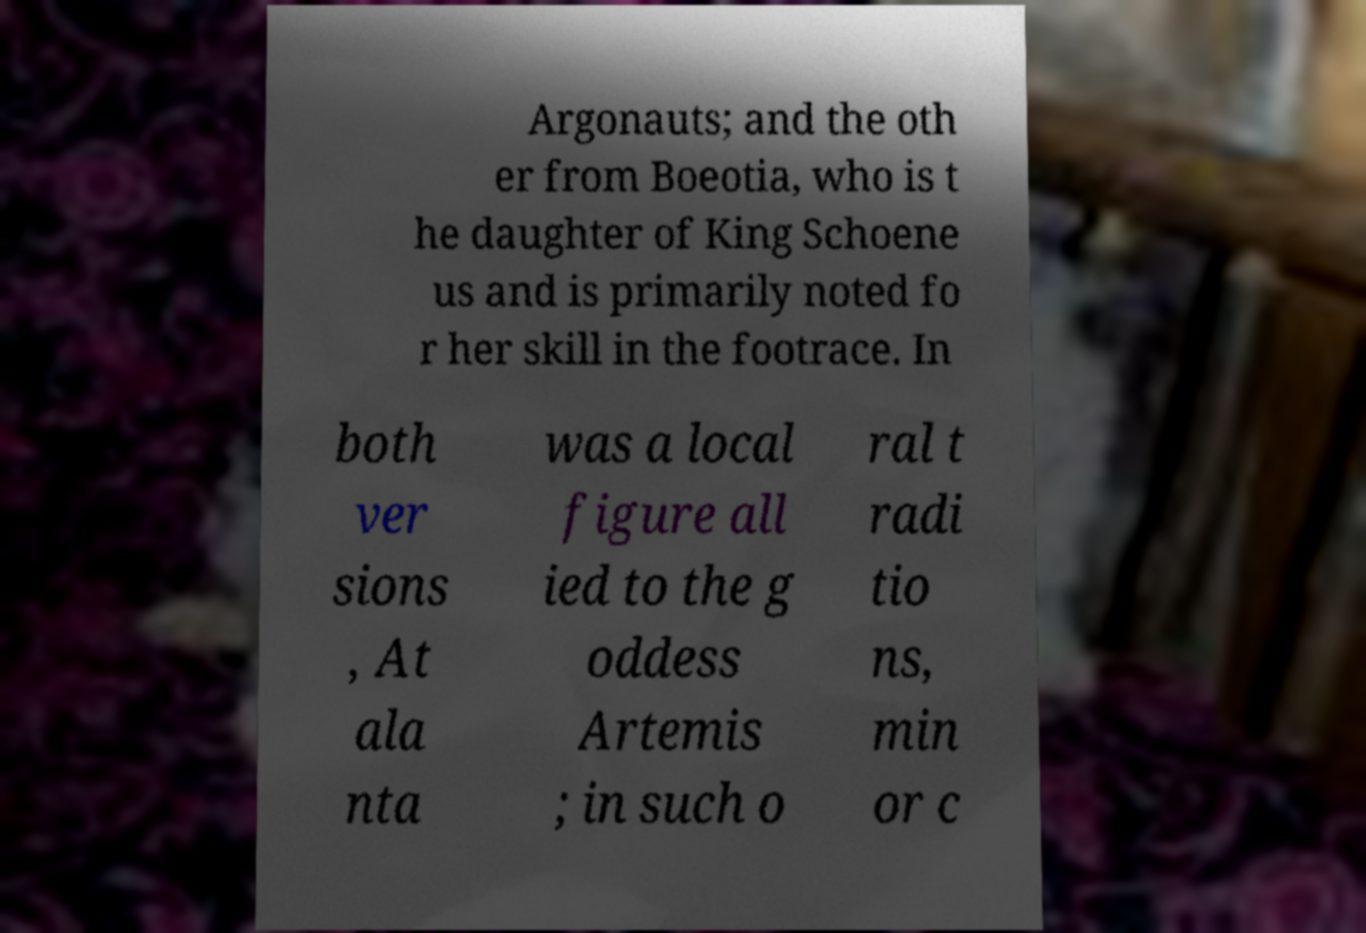Can you accurately transcribe the text from the provided image for me? Argonauts; and the oth er from Boeotia, who is t he daughter of King Schoene us and is primarily noted fo r her skill in the footrace. In both ver sions , At ala nta was a local figure all ied to the g oddess Artemis ; in such o ral t radi tio ns, min or c 